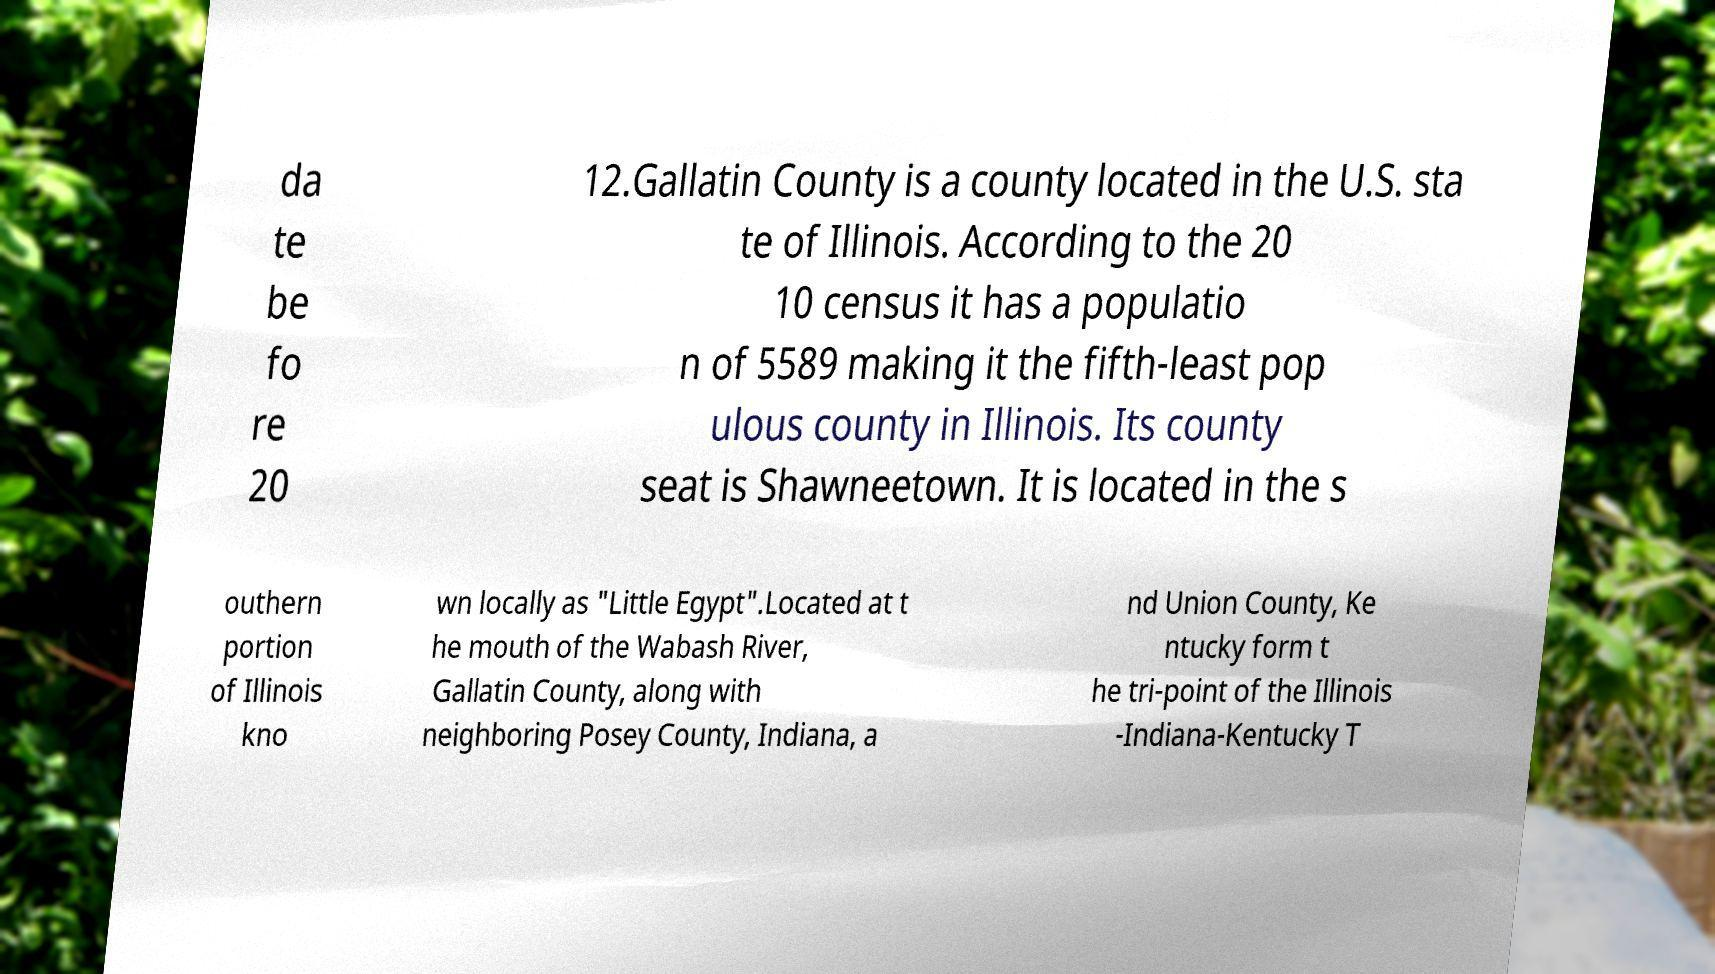Can you read and provide the text displayed in the image?This photo seems to have some interesting text. Can you extract and type it out for me? da te be fo re 20 12.Gallatin County is a county located in the U.S. sta te of Illinois. According to the 20 10 census it has a populatio n of 5589 making it the fifth-least pop ulous county in Illinois. Its county seat is Shawneetown. It is located in the s outhern portion of Illinois kno wn locally as "Little Egypt".Located at t he mouth of the Wabash River, Gallatin County, along with neighboring Posey County, Indiana, a nd Union County, Ke ntucky form t he tri-point of the Illinois -Indiana-Kentucky T 